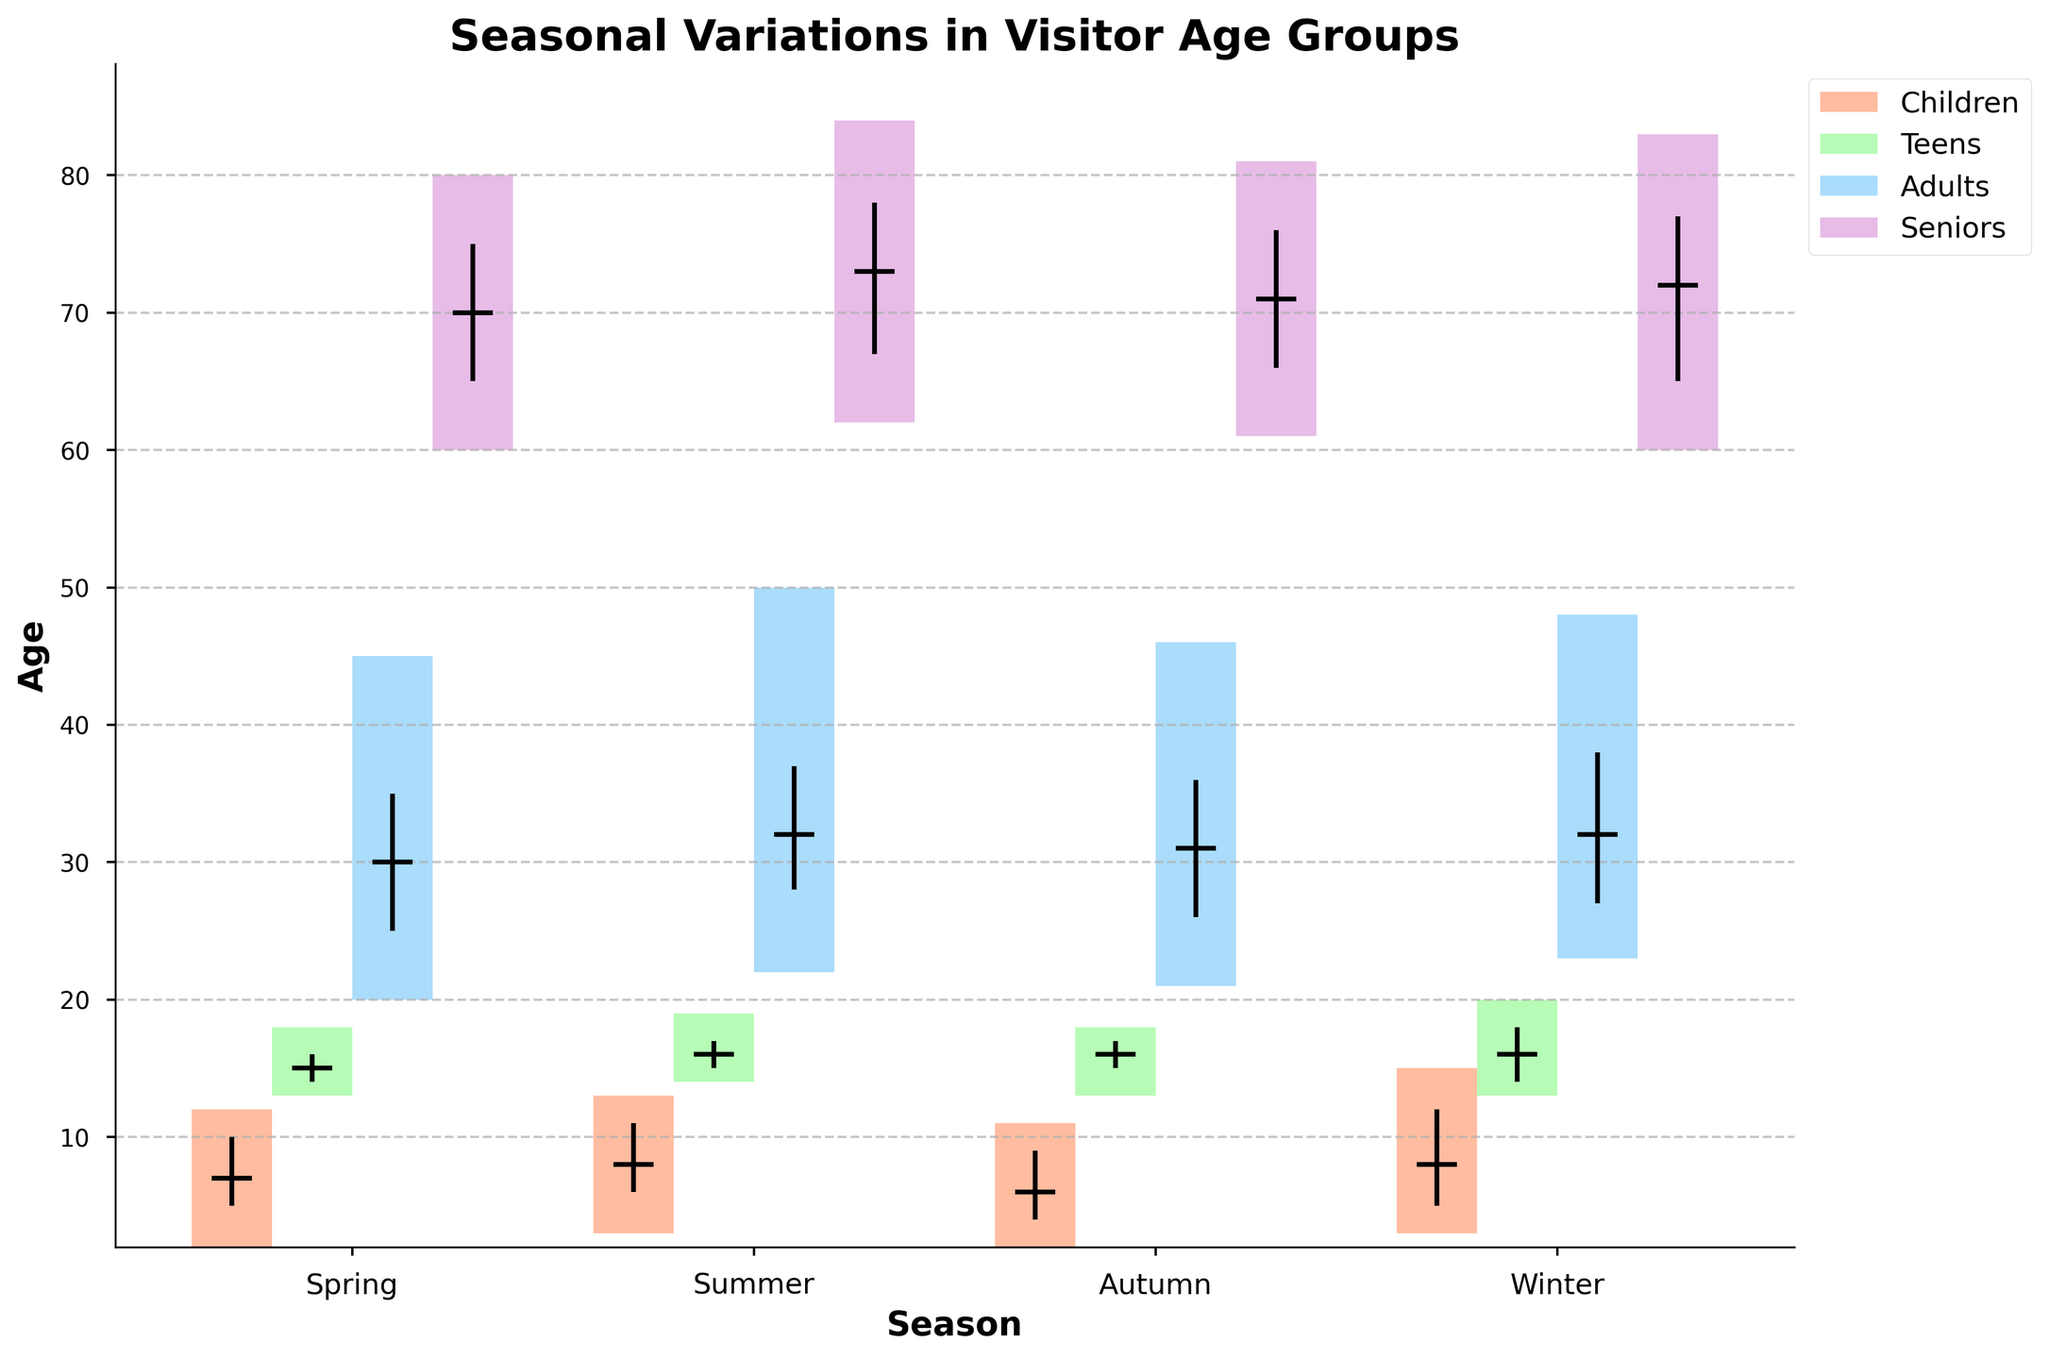What is the title of the figure? The title is usually at the top of the figure and describes the main theme or the topic being illustrated. Look at the top for the text that summarizes the chart.
Answer: Seasonal Variations in Visitor Age Groups What are the four age groups displayed in the plot? The legend on the right side of the plot lists the age groups represented by different colors.
Answer: Children, Teens, Adults, Seniors During which season do children have the widest age range? To find this, compare the lengths of the candlestick bars for children across all seasons. The widest will be the one with the longest bar from Min Age to Max Age.
Answer: Winter What are the median ages for Adults in Winter? Identify the segment for Adults in Winter and look at the short horizontal black line representing the median within that segment.
Answer: 32 Which age group experienced the highest maximum age in any season? Look for the highest point among all age group segments across all seasons, indicated by the top edge of the candlestick bars.
Answer: Adults in Summer What is the interquartile range (IQR) for Seniors in Summer? The IQR is the difference between the third quartile and the first quartile. For Seniors in Summer, find the top and bottom horizontal lines of the box and subtract the values: 78 - 67.
Answer: 11 Which season has the lowest median age for Teens? Compare the median markers (horizontal black lines) for Teens across all seasons and identify the season with the lowest median.
Answer: Spring By how many years does the maximum age of Adults in Summer exceed that of Adults in Winter? Subtract the maximum age of Adults in Winter from the maximum age of Adults in Summer: 50 - 48.
Answer: 2 Among the four seasons, which one shows the smallest overall spread in age for Seniors? Assess the total range (difference between the max and min values) for Seniors across all four seasons and identify the smallest one.
Answer: Spring 